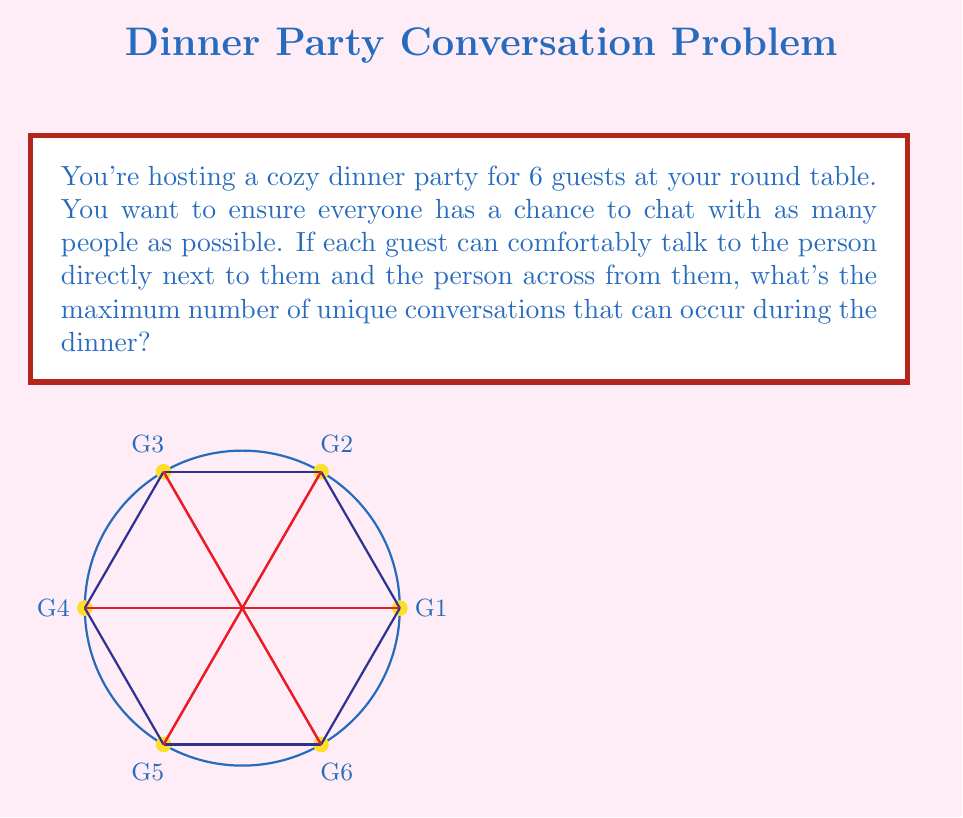What is the answer to this math problem? Let's approach this step-by-step:

1) First, let's count the conversations between adjacent guests:
   - There are 6 pairs of adjacent guests (G1-G2, G2-G3, G3-G4, G4-G5, G5-G6, G6-G1)
   - This gives us 6 unique conversations

2) Now, let's count the conversations between guests across from each other:
   - There are 3 pairs of guests across from each other (G1-G4, G2-G5, G3-G6)
   - This gives us 3 more unique conversations

3) To calculate the total number of unique conversations, we add these together:
   $$6 + 3 = 9$$

4) We can verify this mathematically:
   - Total possible pairs of guests: $\binom{6}{2} = 15$
   - Pairs that can't converse (diagonal): $6 - 3 = 3$
   - Unique conversations: $15 - 3 = 12$

5) However, the question asks for the maximum number of conversations that can occur during the dinner. This implies that not all potential conversations will happen simultaneously.

6) In the optimal arrangement:
   - All 6 adjacent pairs can converse simultaneously
   - 3 across pairs can converse simultaneously

Therefore, the maximum number of unique conversations that can occur during the dinner is indeed 9.
Answer: 9 conversations 